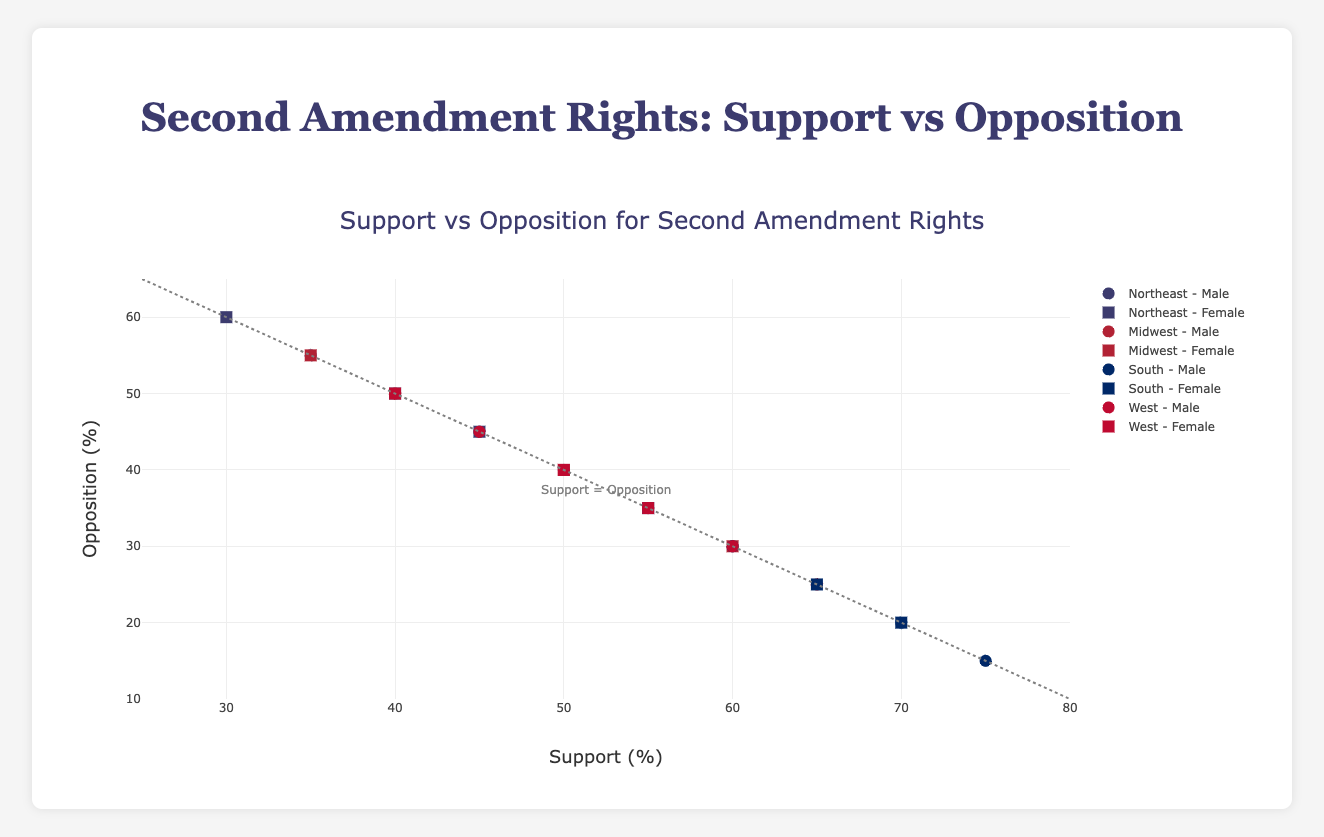What's the title of the figure? The title of the figure is prominently displayed at the top and reads "Second Amendment Rights: Support vs Opposition."
Answer: Second Amendment Rights: Support vs Opposition What are the axes labeled? The x-axis is labeled "Support (%)" and the y-axis is labeled "Opposition (%)."
Answer: Support (%) and Opposition (%) How many data points are in the South - Male group? There are three data points representing the South - Male group, corresponding to the age groups 18-29, 30-44, and 45-64.
Answer: 3 Which region shows the highest support for the Second Amendment rights among males? The South region shows the highest support among males, with support percentages of 60%, 70%, and 75% for the age groups 18-29, 30-44, and 45-64, respectively.
Answer: South Which age group in the Midwest has the least opposition among females? In the Midwest, females in the 45-64 age group have the least opposition at 30%.
Answer: 45-64 Compare the support for Second Amendment rights between males and females in the 30-44 age group in the West region. In the West region, males in the 30-44 age group have 55% support, while females have 50% support. Therefore, males in this age group have a higher support than females.
Answer: Males have higher support Are there any points where support equals opposition? Yes, there are points where support equals opposition: Northeast region for males in the age group 30-44 (45% support and 45% opposition) and Northeast for females in the age group 45-64 (45% support and 45% opposition).
Answer: Yes What is the average support percentage for females in the South? The support percentages for females in the South are 55%, 65%, and 70%. The average support is (55 + 65 + 70) / 3 = 63.33%.
Answer: 63.33% Which region and gender have the highest opposition percentage? The Northeast region for females in the 18-29 age group has the highest opposition at 60%.
Answer: Northeast - Female - 18-29 What is the difference in opposition between the youngest and oldest age groups for males in the Midwest? In the Midwest, opposition for males in the 18-29 age group is 50%, while for the 45-64 age group it is 25%. The difference is 50% - 25% = 25%.
Answer: 25% 